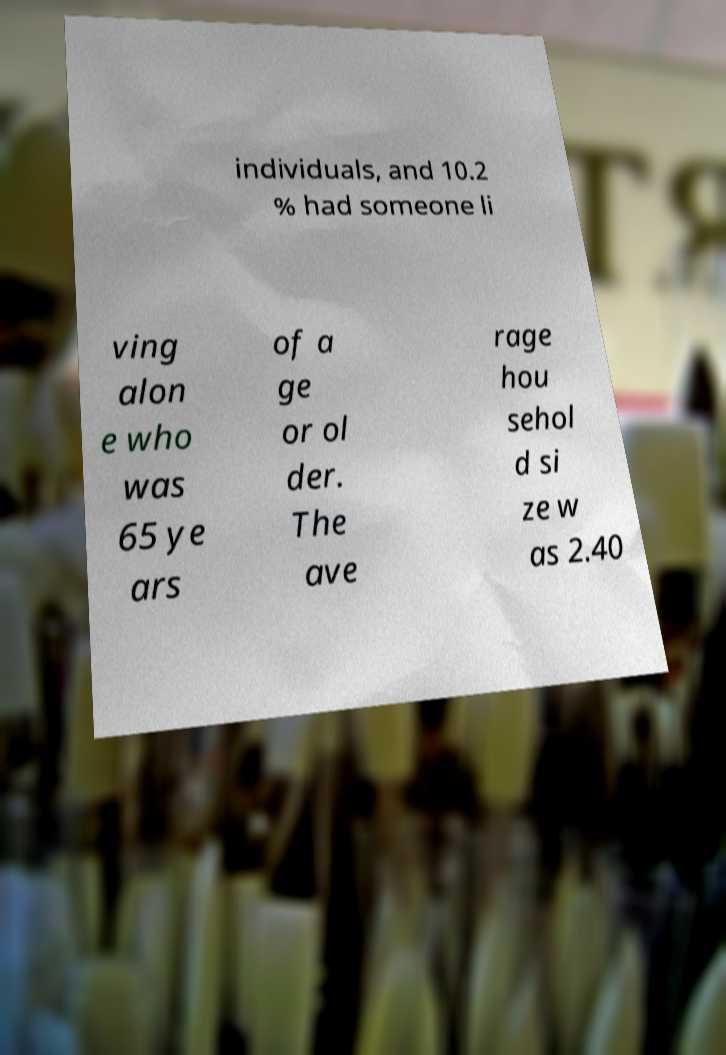What messages or text are displayed in this image? I need them in a readable, typed format. individuals, and 10.2 % had someone li ving alon e who was 65 ye ars of a ge or ol der. The ave rage hou sehol d si ze w as 2.40 